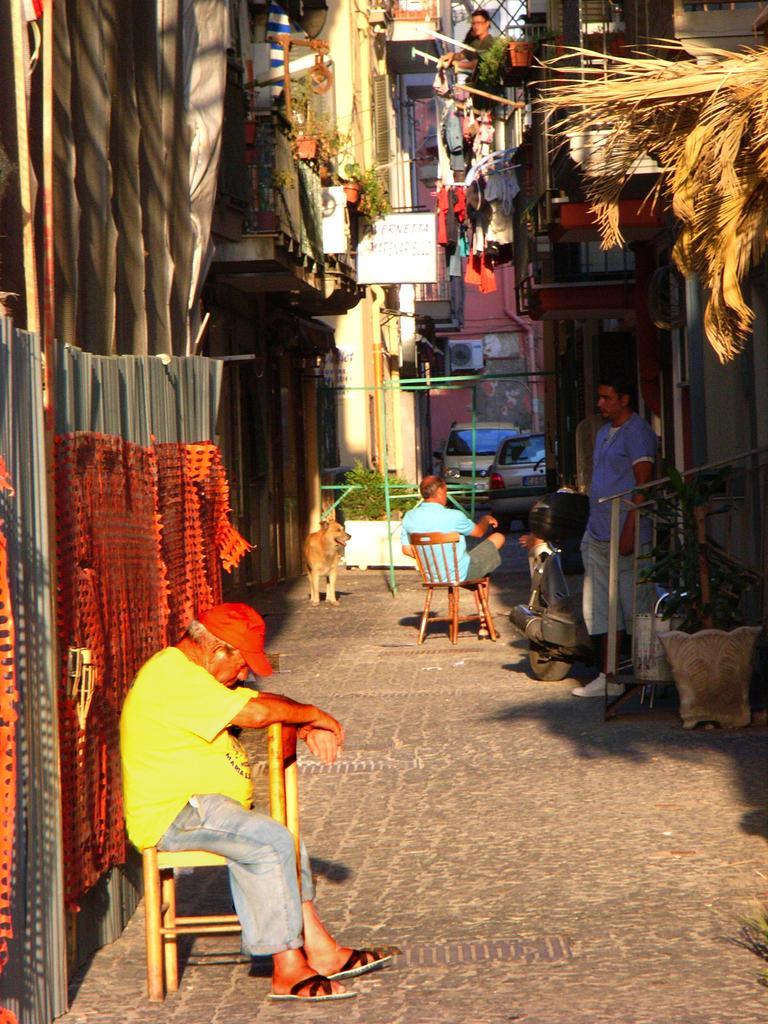Could you give a brief overview of what you see in this image? As we can see in the image there are buildings, plants, road, chairs and two people sitting on chairs and on road there is a dog. 